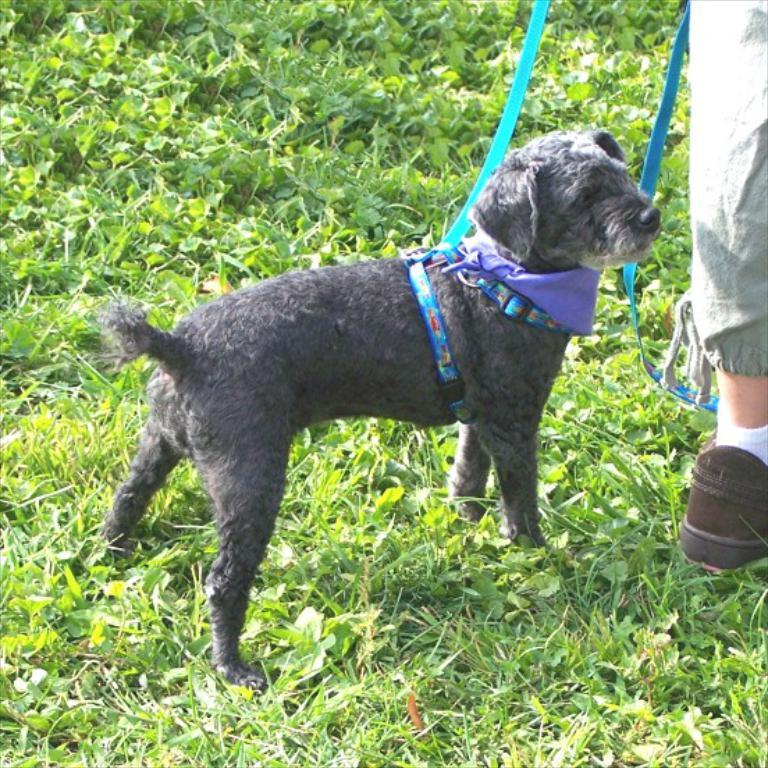What type of animal is in the image? There is a dog in the image. Who or what else is present in the image? There is a person in the image. What other elements can be seen in the image? There are plants in the image. What type of grain is being harvested by the person in the image? There is no grain present in the image, nor is there any indication of harvesting. 